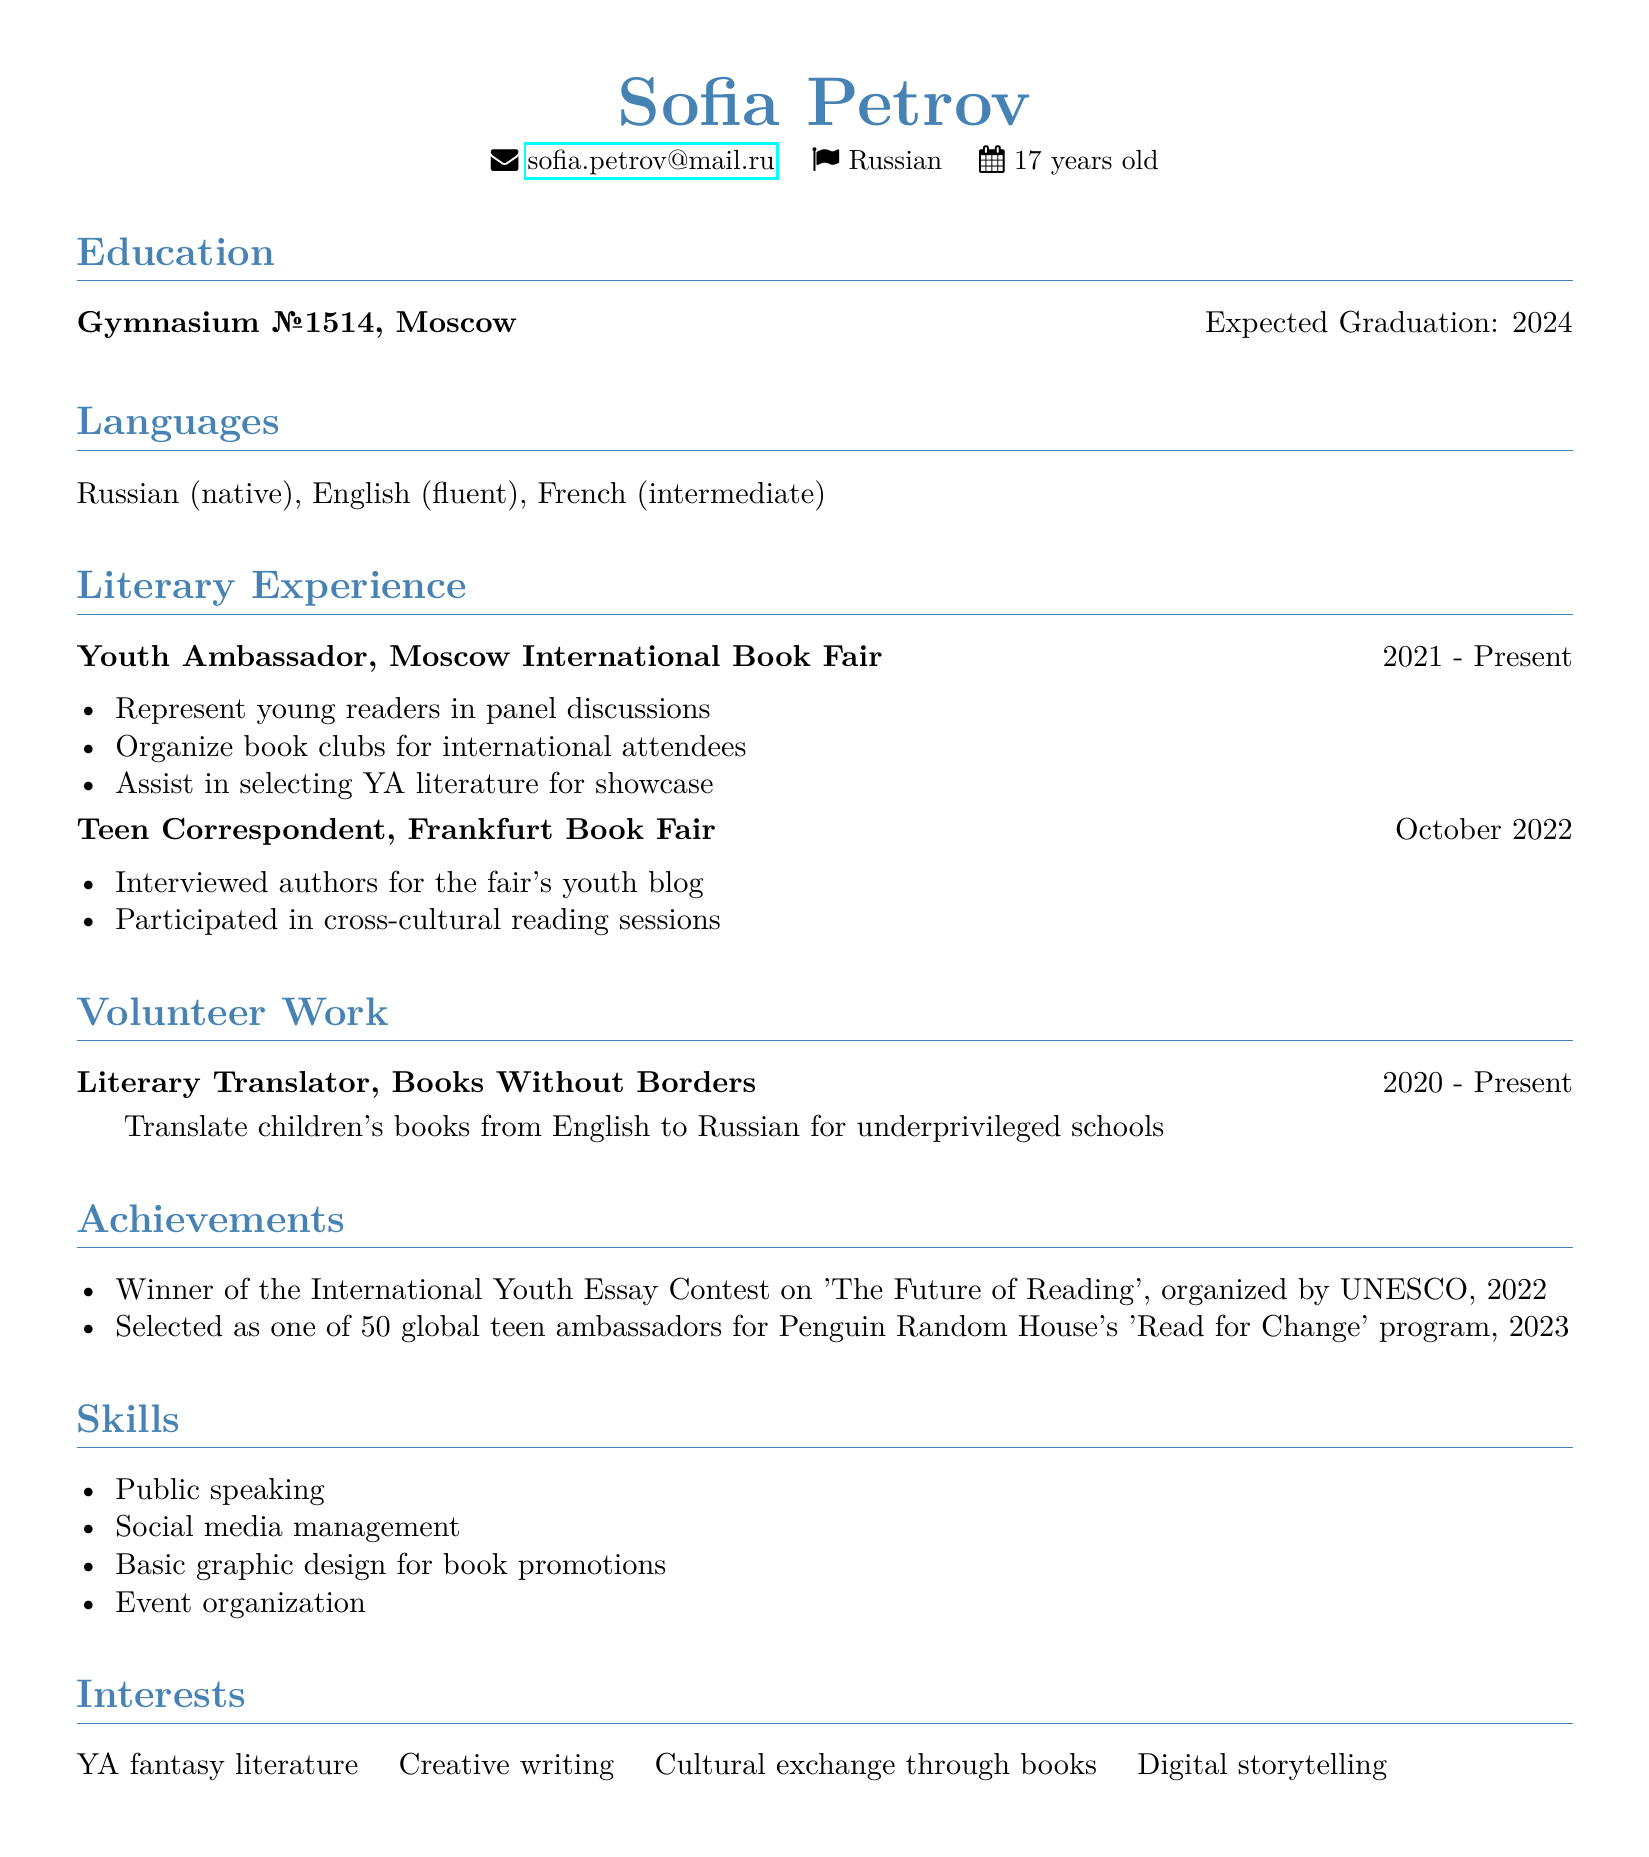What is Sofia Petrov's age? Sofia Petrov's age is explicitly stated in the personal information section of the CV.
Answer: 17 What position does Sofia hold at the Moscow International Book Fair? The CV specifies her role within the organization, highlighting her responsibilities.
Answer: Youth Ambassador In what year did Sofia start volunteering as a Literary Translator? The duration for her volunteer position indicates when she began her work in that role.
Answer: 2020 How many languages can Sofia speak? The languages section of the CV lists the number of languages and their proficiency levels.
Answer: Three What organization selected her as one of the global teen ambassadors? The achievements section mentions the organization associated with this recognition.
Answer: Penguin Random House What type of literature does Sofia organize book clubs around? The responsibilities listed under her role as a Youth Ambassador provide insight into the literature focus.
Answer: YA literature During which event did Sofia serve as a Teen Correspondent? The CV explicitly states the event and the date when she participated in this role.
Answer: Frankfurt Book Fair What type of writing does Sofia have an interest in? The interests section explicitly lists her passions related to writing.
Answer: Creative writing When is Sofia expected to graduate? Her education section states the expected graduation date.
Answer: 2024 